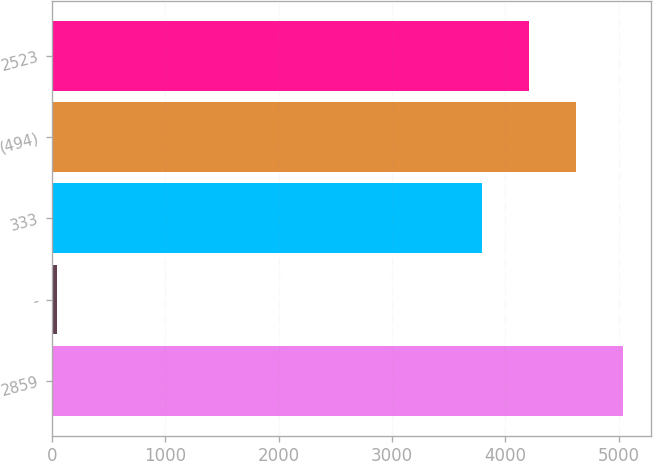<chart> <loc_0><loc_0><loc_500><loc_500><bar_chart><fcel>2859<fcel>-<fcel>333<fcel>(494)<fcel>2523<nl><fcel>5036.4<fcel>42<fcel>3795<fcel>4622.6<fcel>4208.8<nl></chart> 